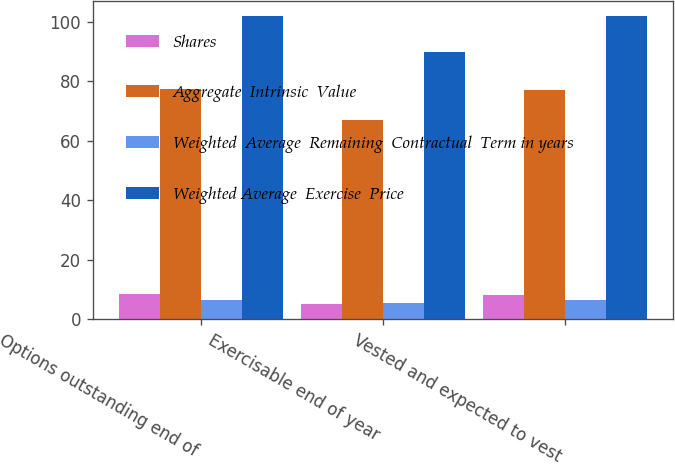Convert chart. <chart><loc_0><loc_0><loc_500><loc_500><stacked_bar_chart><ecel><fcel>Options outstanding end of<fcel>Exercisable end of year<fcel>Vested and expected to vest<nl><fcel>Shares<fcel>8.4<fcel>5.1<fcel>8.3<nl><fcel>Aggregate  Intrinsic  Value<fcel>77.35<fcel>67.17<fcel>76.98<nl><fcel>Weighted  Average  Remaining  Contractual  Term in years<fcel>6.7<fcel>5.6<fcel>6.6<nl><fcel>Weighted Average  Exercise  Price<fcel>102<fcel>90<fcel>102<nl></chart> 